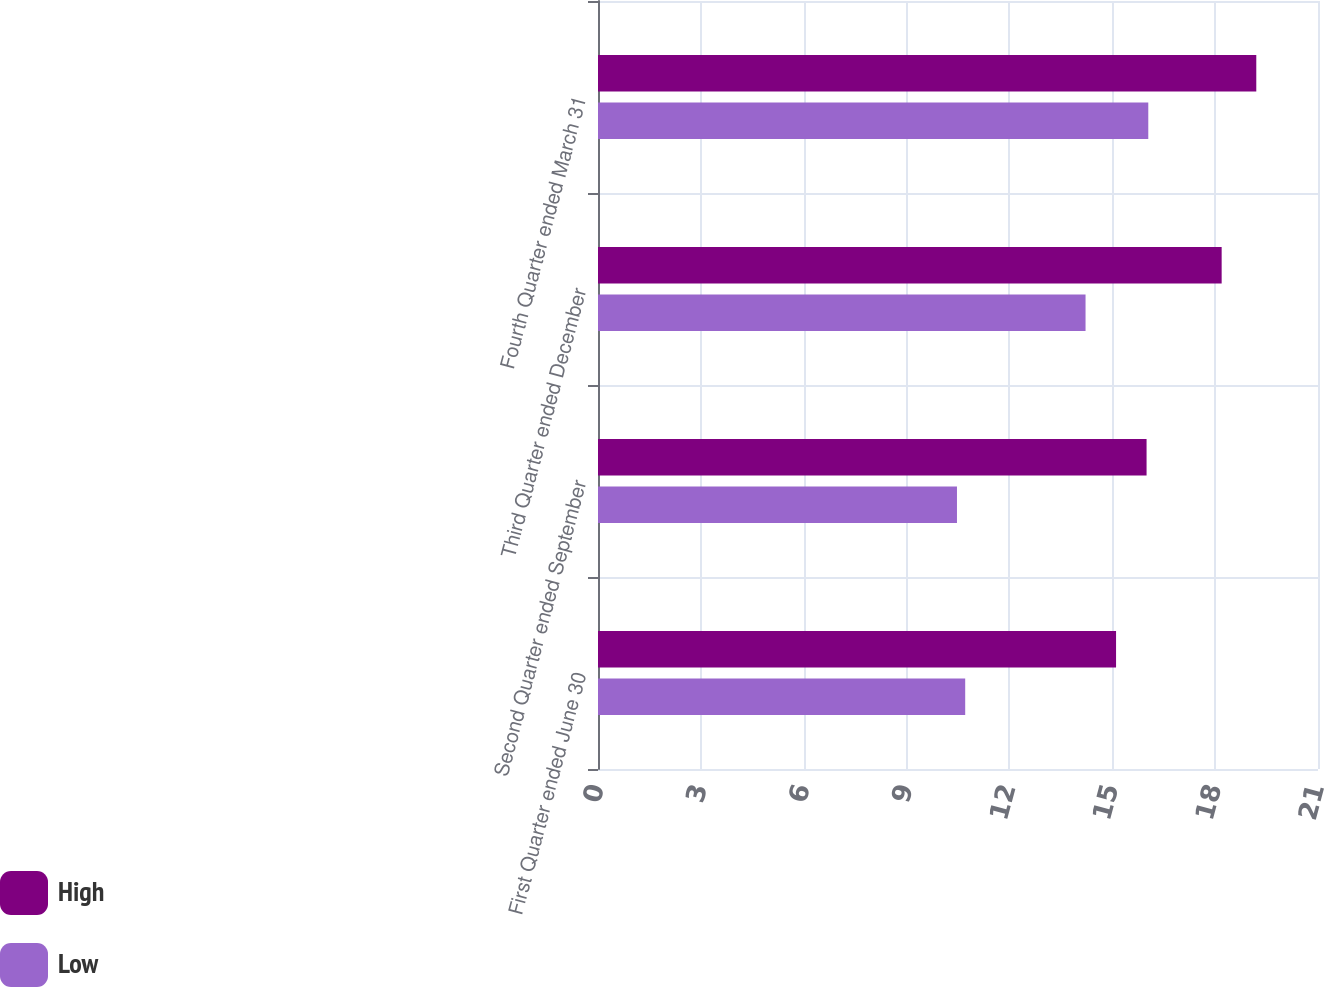Convert chart to OTSL. <chart><loc_0><loc_0><loc_500><loc_500><stacked_bar_chart><ecel><fcel>First Quarter ended June 30<fcel>Second Quarter ended September<fcel>Third Quarter ended December<fcel>Fourth Quarter ended March 31<nl><fcel>High<fcel>15.11<fcel>16<fcel>18.19<fcel>19.2<nl><fcel>Low<fcel>10.71<fcel>10.47<fcel>14.22<fcel>16.05<nl></chart> 